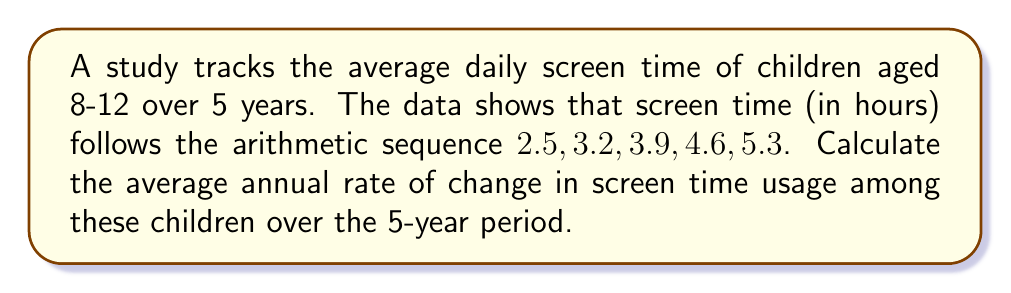Solve this math problem. Let's approach this step-by-step:

1) First, we need to identify the arithmetic sequence:
   $a_1 = 2.5, a_2 = 3.2, a_3 = 3.9, a_4 = 4.6, a_5 = 5.3$

2) In an arithmetic sequence, the common difference $d$ is constant. We can calculate it:
   $d = a_2 - a_1 = 3.2 - 2.5 = 0.7$

3) This common difference represents the increase in screen time each year, in hours.

4) To find the total change over 5 years, we subtract the first term from the last term:
   Total change = $a_5 - a_1 = 5.3 - 2.5 = 2.8$ hours

5) To calculate the average annual rate of change, we divide the total change by the number of years:
   Average annual rate of change = $\frac{2.8 \text{ hours}}{5 \text{ years}} = 0.56$ hours/year

Therefore, the average annual rate of change in screen time usage is 0.56 hours per year.
Answer: 0.56 hours/year 